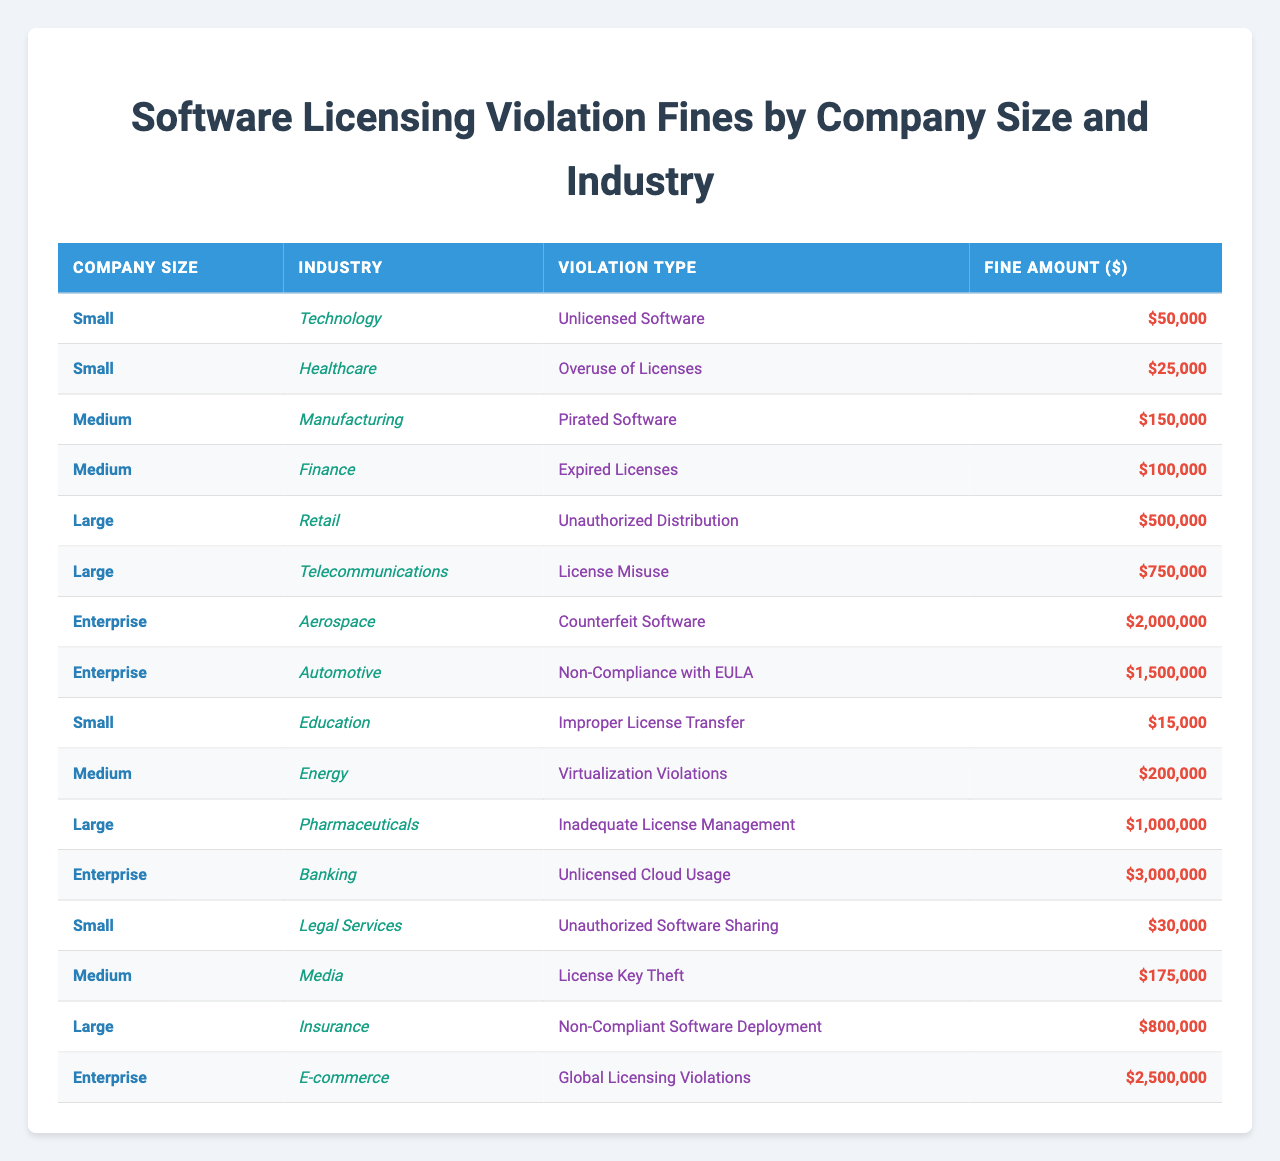What is the highest fine amount listed in the table? The highest fine amount can be found by scanning down the Fine Amount column. The fine for Banking (Enterprise) for Unlicensed Cloud Usage is $3,000,000, which is the highest listed amount.
Answer: 3000000 How many different industries are represented in the table? To find the number of distinct industries, we can list the industries from the Industry column. The unique industries are Technology, Healthcare, Manufacturing, Finance, Retail, Telecommunications, Aerospace, Automotive, Education, Energy, Media, Pharmaceuticals, Banking, and E-commerce, totaling 14 unique industries.
Answer: 14 What is the total fine amount for Small companies? By identifying all the fines associated with Small companies (Technology, Healthcare, Education, Legal Services), we can sum them: 50,000 + 25,000 + 15,000 + 30,000 = 120,000.
Answer: 120000 Is there a violation type that is common among multiple company sizes? Reviewing the Violation Type column against the Company Size column, "License Misuse" appears only in Large companies, while "Expired Licenses" occurs only in Medium. No violation type is repeated across multiple sizes; thus, the answer is no.
Answer: No What is the average fine for Medium-sized companies? The fines for Medium companies (Manufacturing, Finance, Energy, Media) are 150,000, 100,000, 200,000, and 175,000. First, we find the sum: 150,000 + 100,000 + 200,000 + 175,000 = 625,000. Then, we divide by 4 (the number of Medium companies): 625,000 / 4 = 156,250.
Answer: 156250 Which industry has the highest fine listed for Small companies? Looking through the fines attributed to Small companies, Technology's fine is $50,000, Healthcare's is $25,000, and the highest is Education with $15,000. Thus, Technology has the highest fine among them at $50,000.
Answer: Technology What is the sum of fines for all Large companies? The fines for Large companies are: Retail (500,000), Telecommunications (750,000), Pharmaceuticals (1,000,000), and Insurance (800,000). Summing these: 500,000 + 750,000 + 1,000,000 + 800,000 = 3,050,000.
Answer: 3050000 Is the fine for "Counterfeit Software" the highest fine overall? "Counterfeit Software" corresponds to an Enterprise company that has a fine of $2,000,000. Comparing this to the other fines listed in the table, the highest fine is found in Banking for $3,000,000, making the answer no.
Answer: No What percentage of the total fines is accounted for by the Enterprise companies? First, sum the fines of Enterprise companies: 2,000,000 + 1,500,000 + 3,000,000 + 2,500,000 = 9,000,000. Then, calculate the total fines: 50,000 + 25,000 + 150,000 + 100,000 + 500,000 + 750,000 + 2,000,000 + 1,500,000 + 15,000 + 200,000 + 1,000,000 + 3,000,000 + 30,000 + 175,000 + 800,000 + 2,500,000 = 12,600,000. The percentage is (9,000,000 / 12,600,000) * 100 ≈ 71.4%.
Answer: 71.4 How many violations fall under the category of 'License Management'? On reviewing the tables, only the Pharmaceutical's fine of $1,000,000 for 'Inadequate License Management' fits this description. Therefore, there is just one violation matching this criteria.
Answer: 1 